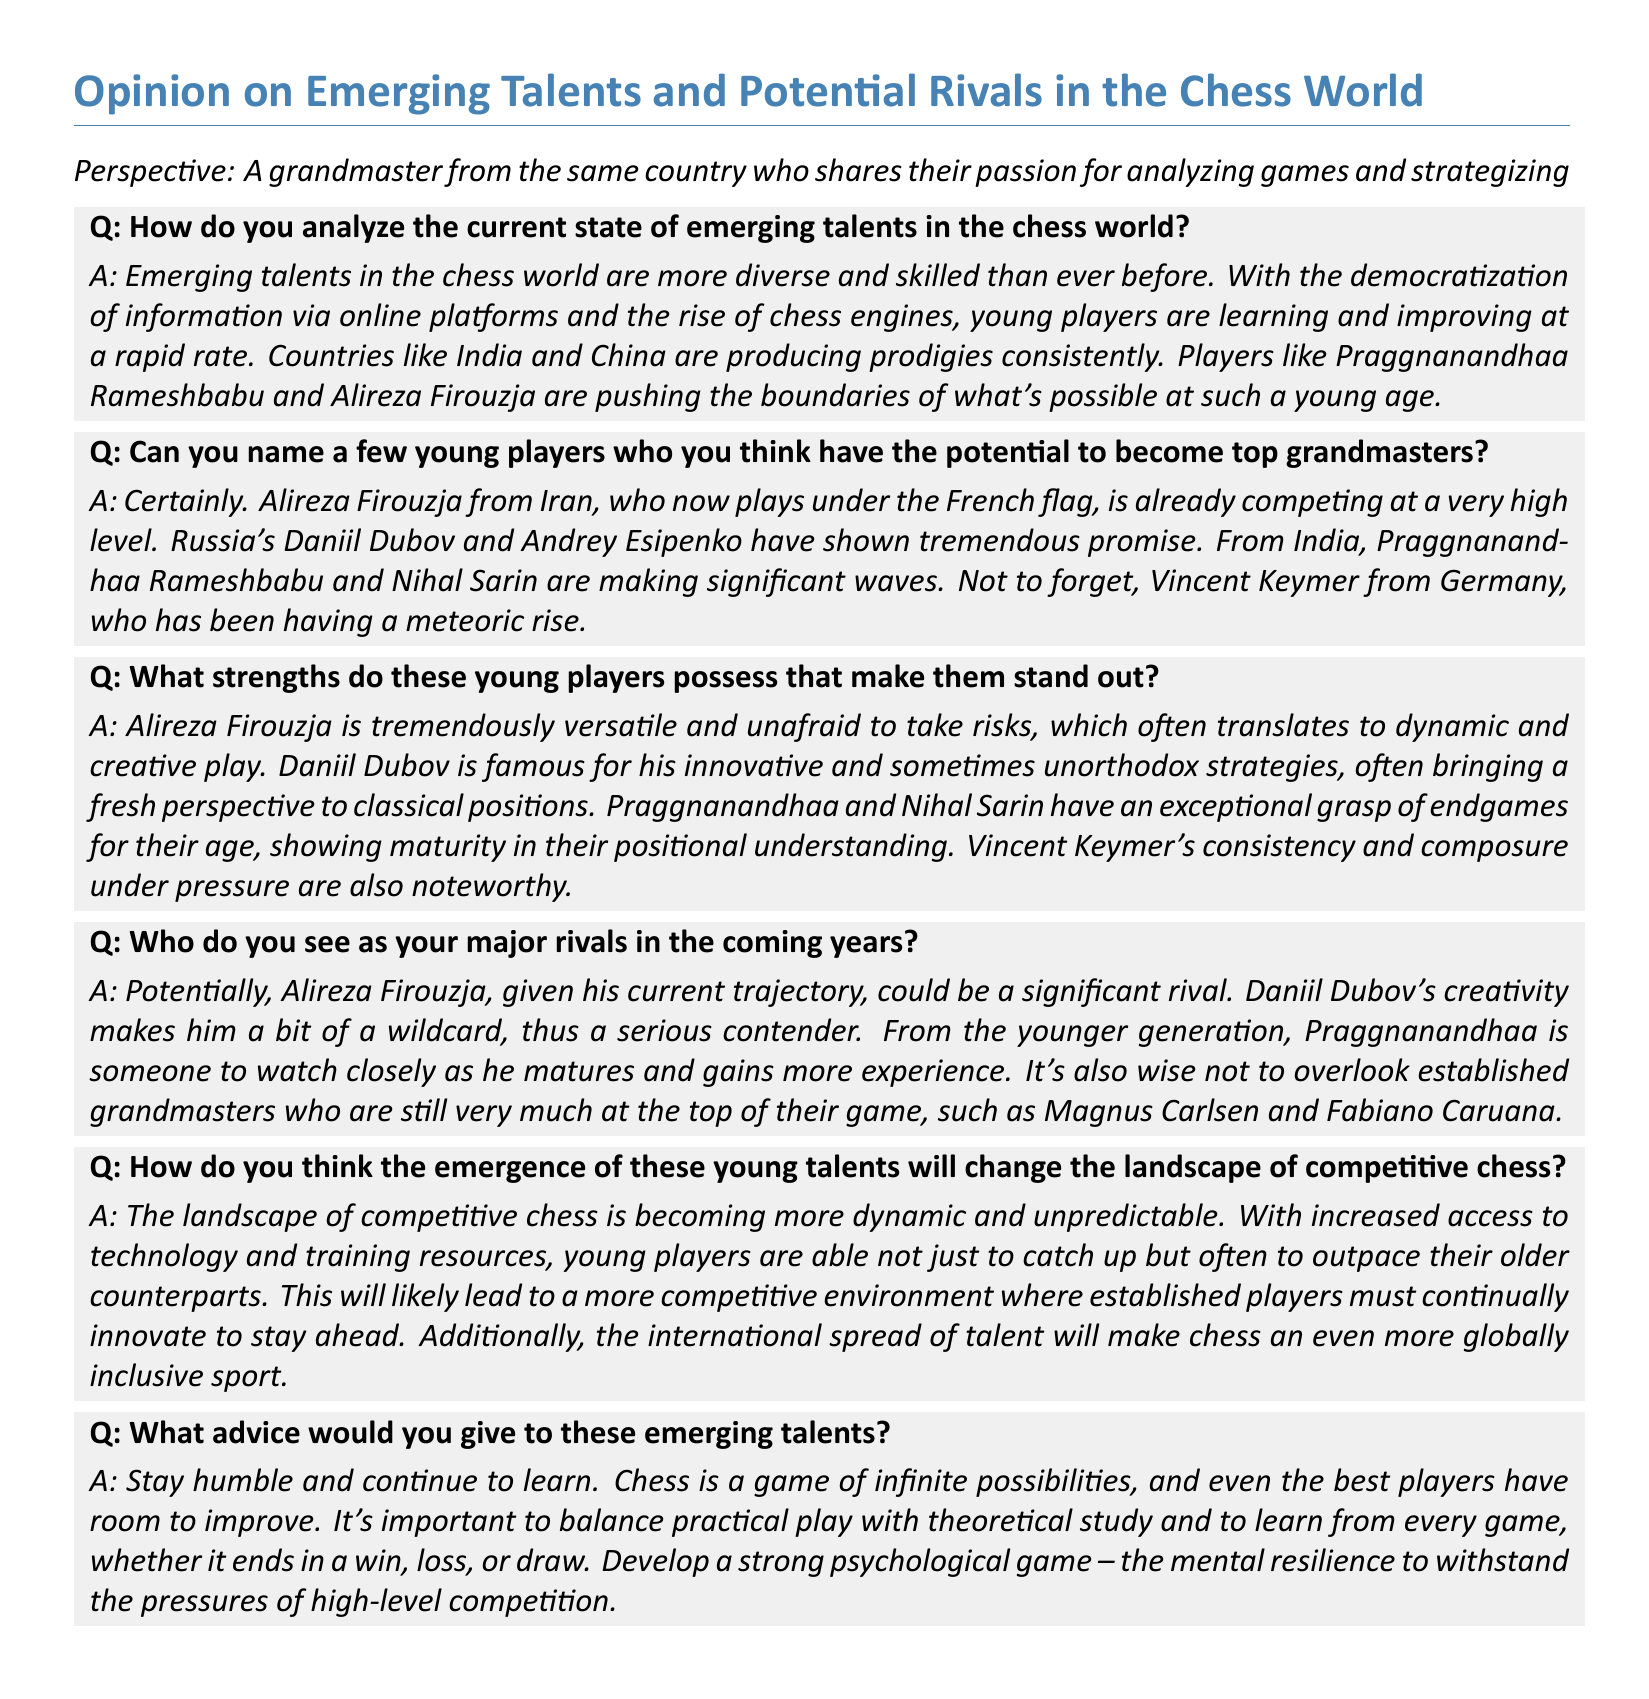What are the names of two young players mentioned as having potential? The document lists multiple players, including Alireza Firouzja and Praggnanandhaa Rameshbabu, as examples of young players with potential.
Answer: Alireza Firouzja, Praggnanandhaa Rameshbabu What notable strength does Alireza Firouzja possess? According to the document, Alireza Firouzja is described as being tremendously versatile and unafraid to take risks, which leads to dynamic play.
Answer: Versatile and unafraid to take risks Which country's players are producing many young talents? The document mentions countries like India and China as currently producing many chess prodigies.
Answer: India and China Who is mentioned as a major rival in the coming years? The document highlights Alireza Firouzja as a significant potential rival for the individual providing the perspective.
Answer: Alireza Firouzja What is the key advice given to emerging talents? The advice given emphasizes the importance of humility and continuous learning in chess, illustrating the need for ongoing personal improvement.
Answer: Stay humble and continue to learn How will the landscape of competitive chess change due to young talents? The emergence of young talents is expected to make the chess landscape more dynamic and unpredictable, influencing how established players approach the game.
Answer: More dynamic and unpredictable What is one trait of Daniil Dubov as mentioned in the document? Daniil Dubov is described in the document as being famous for his innovative and sometimes unorthodox strategies.
Answer: Innovative and unorthodox strategies What does the document suggest about the role of technology in chess? The document indicates that technology and training resources are allowing young players to catch up and often outpace their older counterparts in chess.
Answer: Catch up and outpace older counterparts 